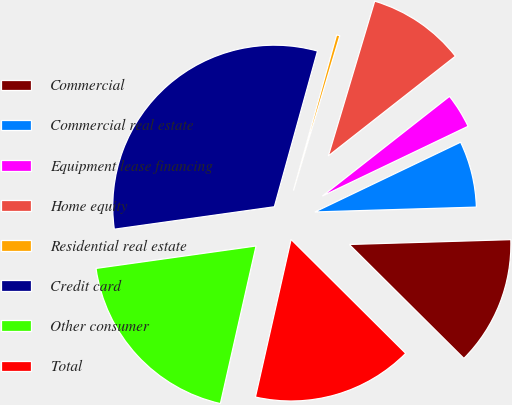<chart> <loc_0><loc_0><loc_500><loc_500><pie_chart><fcel>Commercial<fcel>Commercial real estate<fcel>Equipment lease financing<fcel>Home equity<fcel>Residential real estate<fcel>Credit card<fcel>Other consumer<fcel>Total<nl><fcel>12.93%<fcel>6.63%<fcel>3.48%<fcel>9.78%<fcel>0.33%<fcel>31.52%<fcel>19.24%<fcel>16.09%<nl></chart> 